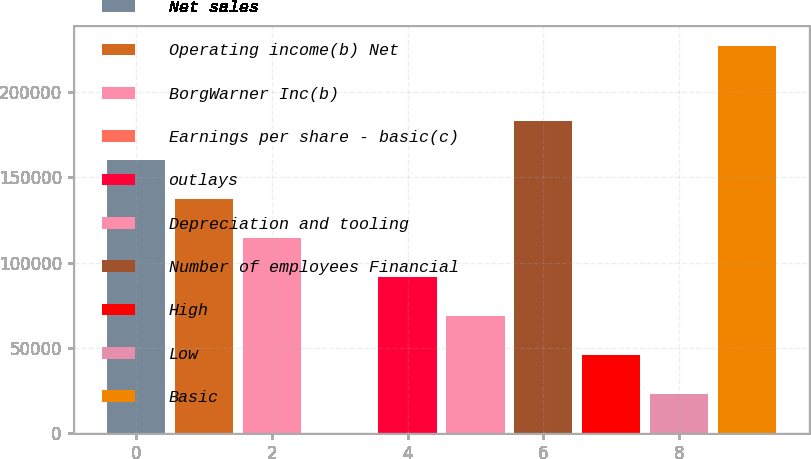Convert chart to OTSL. <chart><loc_0><loc_0><loc_500><loc_500><bar_chart><fcel>Net sales<fcel>Operating income(b) Net<fcel>BorgWarner Inc(b)<fcel>Earnings per share - basic(c)<fcel>outlays<fcel>Depreciation and tooling<fcel>Number of employees Financial<fcel>High<fcel>Low<fcel>Basic<nl><fcel>160248<fcel>137356<fcel>114463<fcel>2.89<fcel>91571.3<fcel>68679.2<fcel>183140<fcel>45787.1<fcel>22895<fcel>227150<nl></chart> 